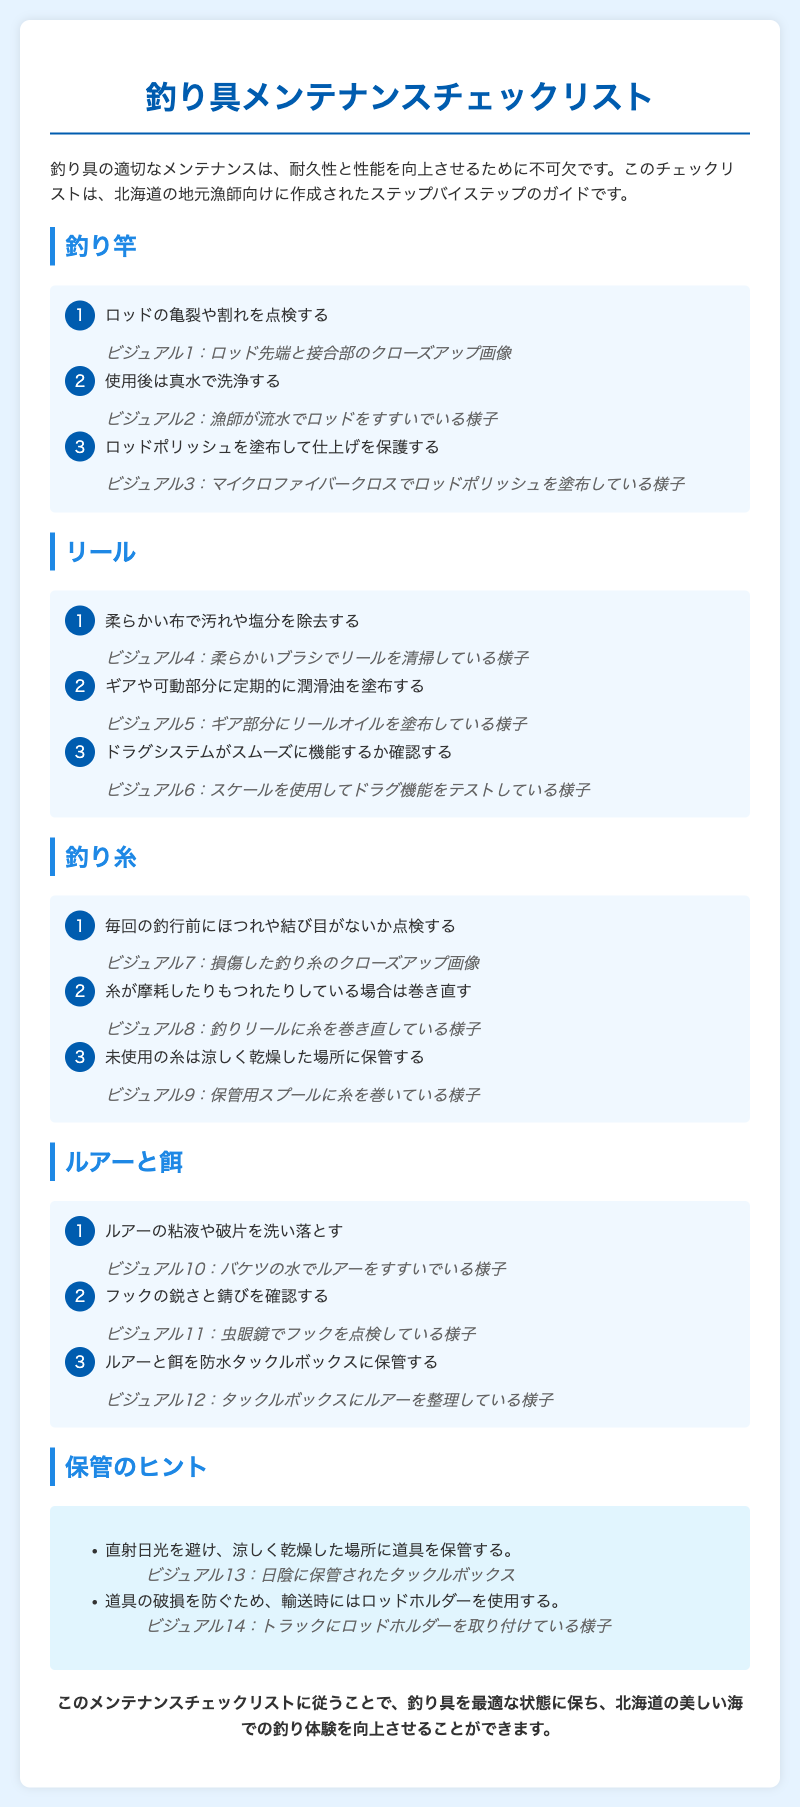何が釣り竿の最初の点検項目？ 釣り竿の項目には「ロッドの亀裂や割れを点検する」と記載されている。
Answer: ロッドの亀裂や割れを点検する リールのメンテナンスで使用する道具は？ リールのメンテナンス項目では「柔らかい布で汚れや塩分を除去する」と書かれている。
Answer: 柔らかい布 釣り糸の摩耗を確認する頻度は？ 釣り糸に関する項目で、「毎回の釣行前にほつれや結び目がないか点検する」と記載されている。
Answer: 毎回の釣行前 ルアーと餌はどこに保管すべき？ ルアーと餌の項目には「防水タックルボックスに保管する」と記載されている。
Answer: 防水タックルボックス 釣り具を保管する際の注意点は？ 保管のヒントに「直射日光を避け、涼しく乾燥した場所に道具を保管する」と書かれている。
Answer: 直射日光を避け、涼しく乾燥した場所 リールのドラグシステムに関する確認項目は何ですか？ リールの手順には「ドラグシステムがスムーズに機能するか確認する」と記載されている。
Answer: ドラグシステムがスムーズに機能するか確認する 